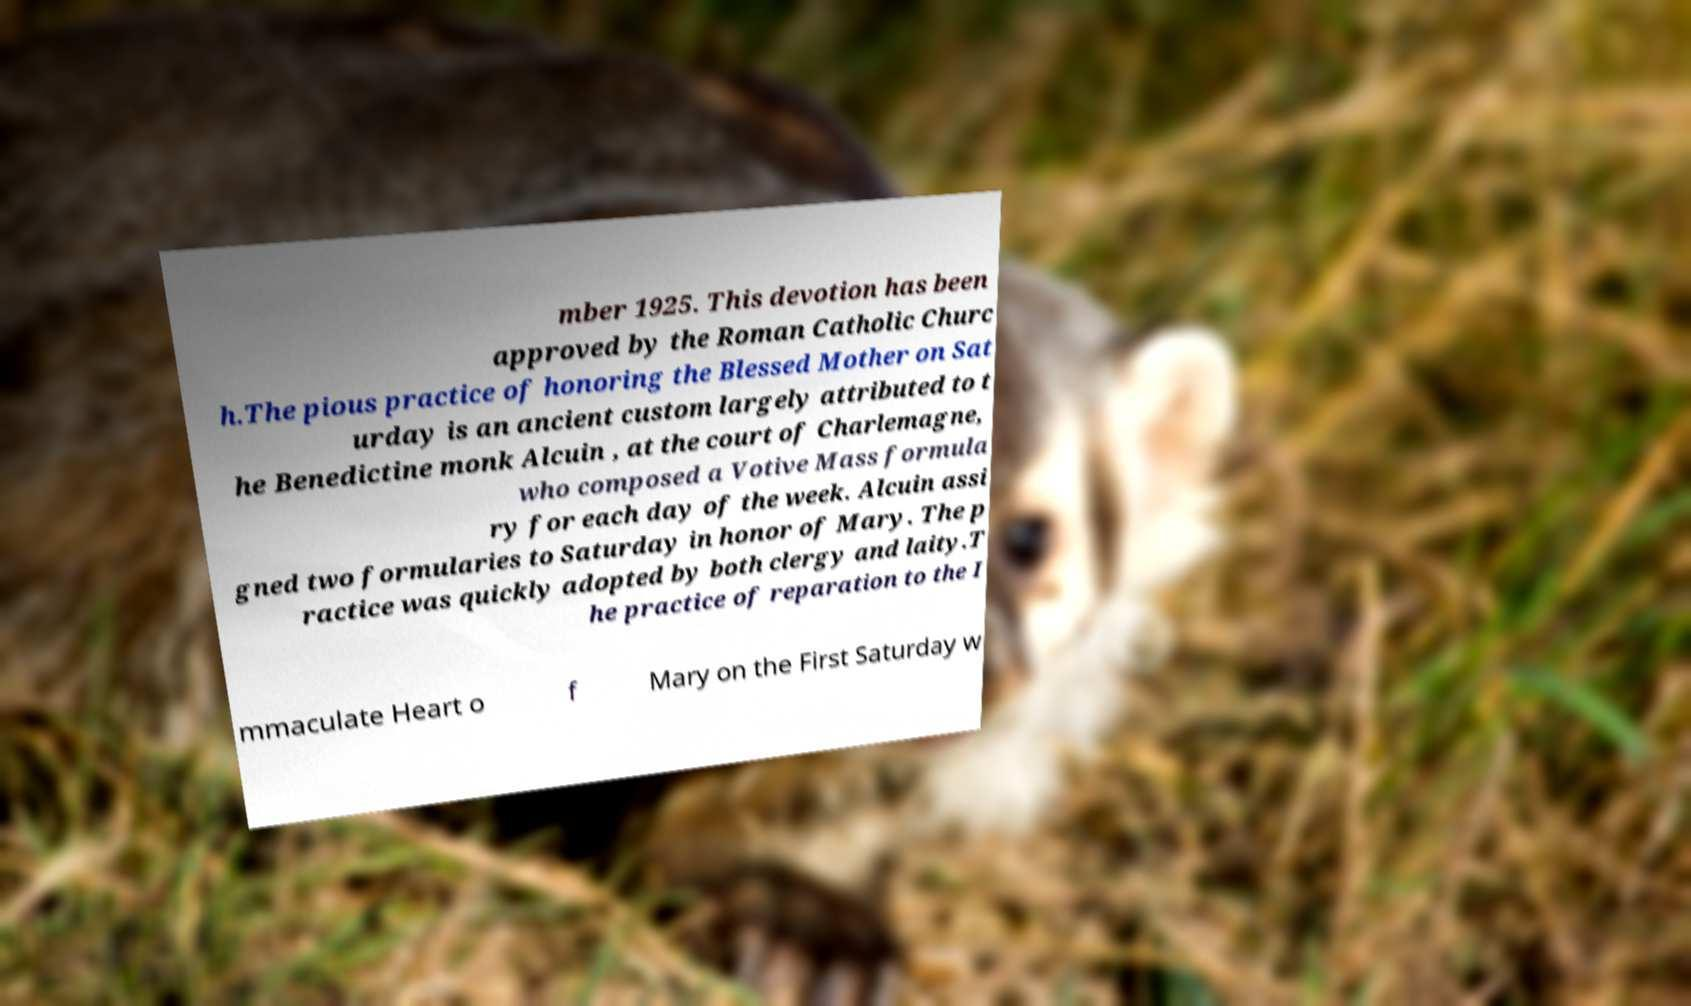There's text embedded in this image that I need extracted. Can you transcribe it verbatim? mber 1925. This devotion has been approved by the Roman Catholic Churc h.The pious practice of honoring the Blessed Mother on Sat urday is an ancient custom largely attributed to t he Benedictine monk Alcuin , at the court of Charlemagne, who composed a Votive Mass formula ry for each day of the week. Alcuin assi gned two formularies to Saturday in honor of Mary. The p ractice was quickly adopted by both clergy and laity.T he practice of reparation to the I mmaculate Heart o f Mary on the First Saturday w 